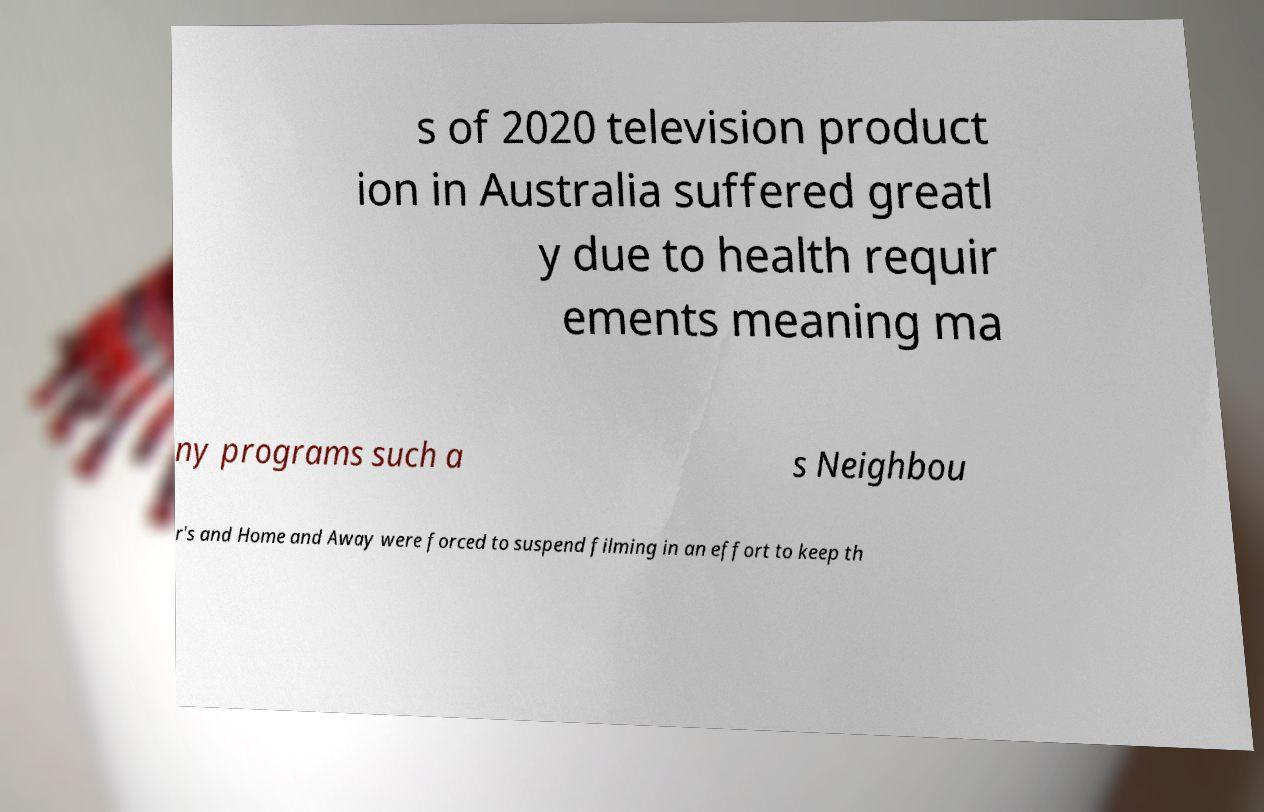I need the written content from this picture converted into text. Can you do that? s of 2020 television product ion in Australia suffered greatl y due to health requir ements meaning ma ny programs such a s Neighbou r's and Home and Away were forced to suspend filming in an effort to keep th 